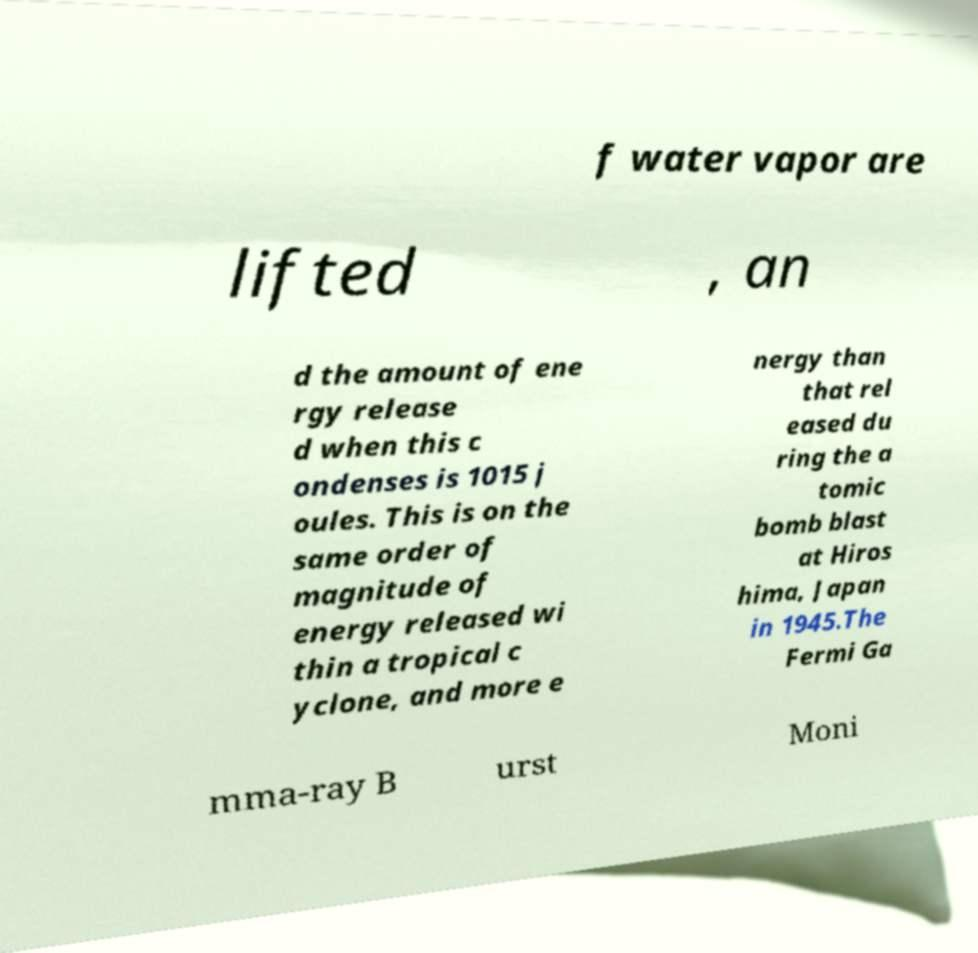Please read and relay the text visible in this image. What does it say? f water vapor are lifted , an d the amount of ene rgy release d when this c ondenses is 1015 j oules. This is on the same order of magnitude of energy released wi thin a tropical c yclone, and more e nergy than that rel eased du ring the a tomic bomb blast at Hiros hima, Japan in 1945.The Fermi Ga mma-ray B urst Moni 